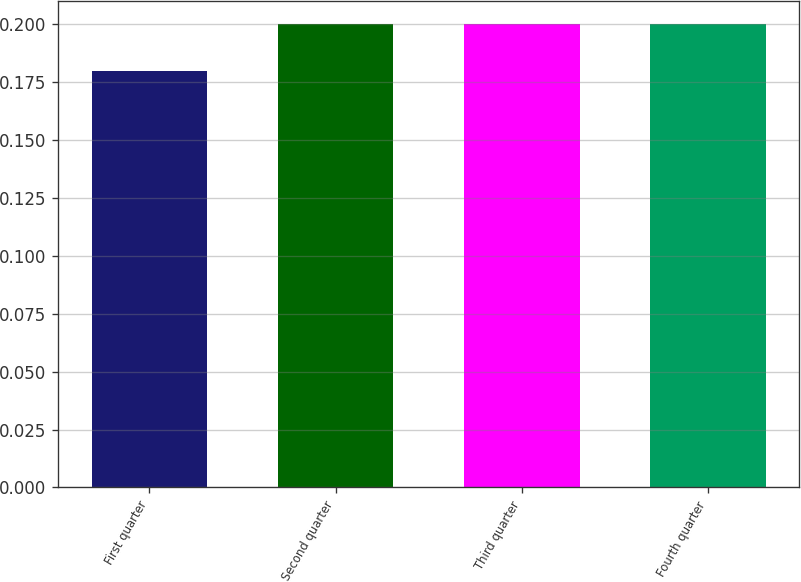Convert chart to OTSL. <chart><loc_0><loc_0><loc_500><loc_500><bar_chart><fcel>First quarter<fcel>Second quarter<fcel>Third quarter<fcel>Fourth quarter<nl><fcel>0.18<fcel>0.2<fcel>0.2<fcel>0.2<nl></chart> 